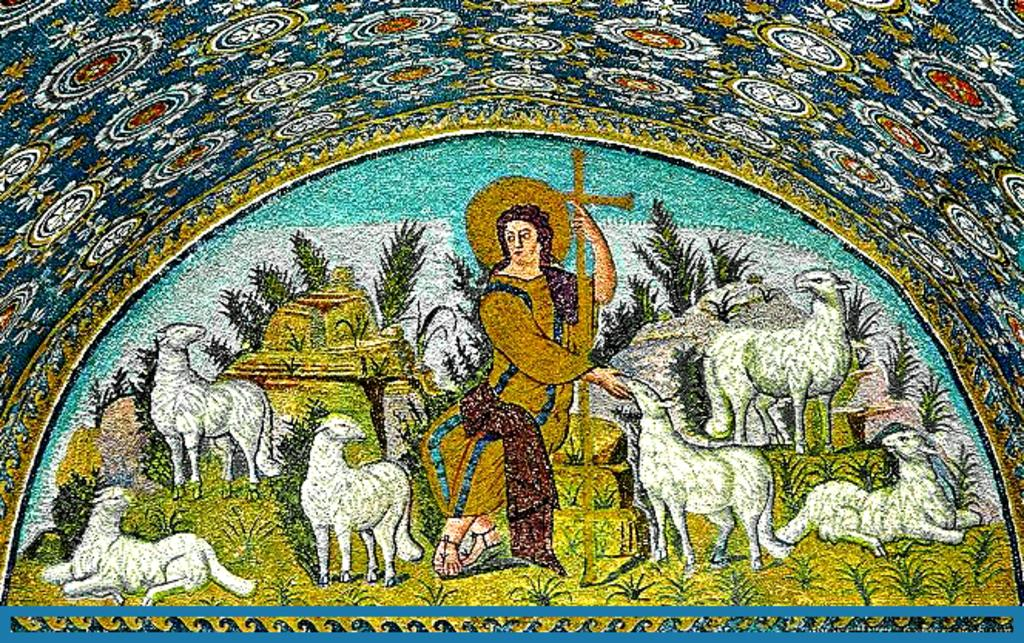What type of animals are depicted in the painting? The painting contains sheep. contains sheep. What other elements can be seen in the painting? The painting contains plants. What is the person in the painting doing? A person is sitting in the painting and holding a holy cross. What type of thread is being used by the sheep in the painting? There is no thread present in the painting, as it features sheep, plants, and a person holding a holy cross. 